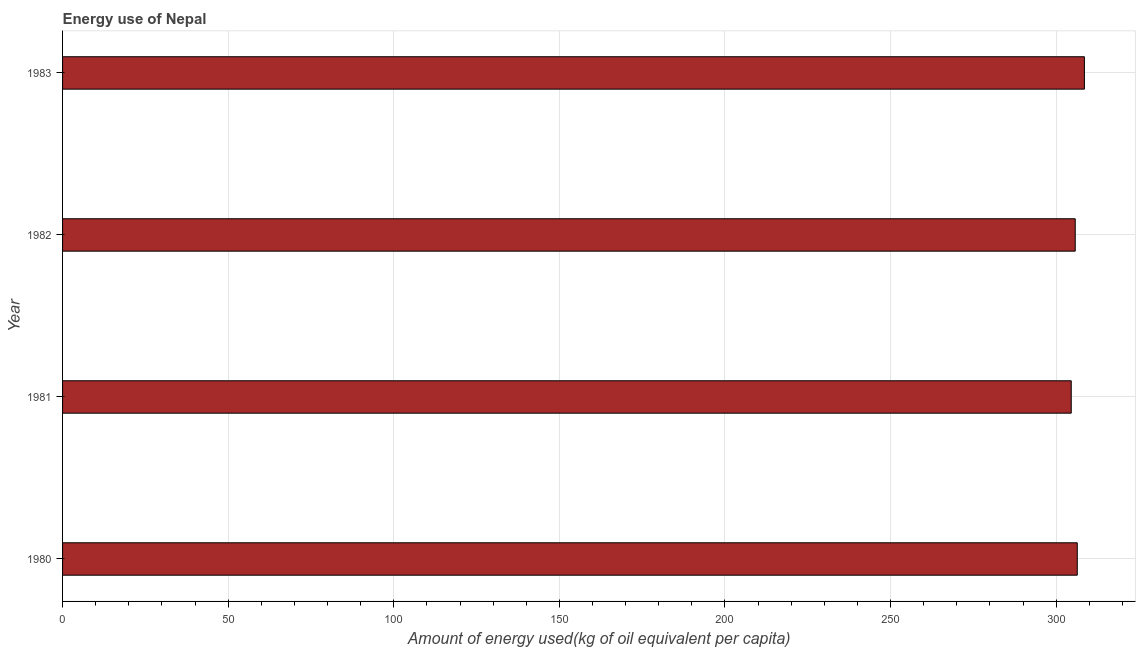What is the title of the graph?
Ensure brevity in your answer.  Energy use of Nepal. What is the label or title of the X-axis?
Offer a very short reply. Amount of energy used(kg of oil equivalent per capita). What is the label or title of the Y-axis?
Your answer should be very brief. Year. What is the amount of energy used in 1983?
Your response must be concise. 308.52. Across all years, what is the maximum amount of energy used?
Your response must be concise. 308.52. Across all years, what is the minimum amount of energy used?
Make the answer very short. 304.54. In which year was the amount of energy used maximum?
Provide a succinct answer. 1983. In which year was the amount of energy used minimum?
Offer a very short reply. 1981. What is the sum of the amount of energy used?
Keep it short and to the point. 1225.16. What is the difference between the amount of energy used in 1982 and 1983?
Provide a short and direct response. -2.77. What is the average amount of energy used per year?
Keep it short and to the point. 306.29. What is the median amount of energy used?
Your answer should be compact. 306.05. In how many years, is the amount of energy used greater than 290 kg?
Provide a short and direct response. 4. Do a majority of the years between 1982 and 1983 (inclusive) have amount of energy used greater than 40 kg?
Your answer should be very brief. Yes. What is the ratio of the amount of energy used in 1980 to that in 1983?
Offer a terse response. 0.99. Is the difference between the amount of energy used in 1980 and 1982 greater than the difference between any two years?
Provide a succinct answer. No. What is the difference between the highest and the second highest amount of energy used?
Your answer should be very brief. 2.15. What is the difference between the highest and the lowest amount of energy used?
Your answer should be very brief. 3.98. In how many years, is the amount of energy used greater than the average amount of energy used taken over all years?
Your answer should be compact. 2. How many bars are there?
Your answer should be very brief. 4. How many years are there in the graph?
Your answer should be very brief. 4. What is the difference between two consecutive major ticks on the X-axis?
Your response must be concise. 50. What is the Amount of energy used(kg of oil equivalent per capita) of 1980?
Ensure brevity in your answer.  306.36. What is the Amount of energy used(kg of oil equivalent per capita) in 1981?
Give a very brief answer. 304.54. What is the Amount of energy used(kg of oil equivalent per capita) of 1982?
Your answer should be compact. 305.75. What is the Amount of energy used(kg of oil equivalent per capita) of 1983?
Provide a succinct answer. 308.52. What is the difference between the Amount of energy used(kg of oil equivalent per capita) in 1980 and 1981?
Give a very brief answer. 1.82. What is the difference between the Amount of energy used(kg of oil equivalent per capita) in 1980 and 1982?
Make the answer very short. 0.61. What is the difference between the Amount of energy used(kg of oil equivalent per capita) in 1980 and 1983?
Your response must be concise. -2.15. What is the difference between the Amount of energy used(kg of oil equivalent per capita) in 1981 and 1982?
Make the answer very short. -1.21. What is the difference between the Amount of energy used(kg of oil equivalent per capita) in 1981 and 1983?
Provide a short and direct response. -3.98. What is the difference between the Amount of energy used(kg of oil equivalent per capita) in 1982 and 1983?
Make the answer very short. -2.77. What is the ratio of the Amount of energy used(kg of oil equivalent per capita) in 1980 to that in 1983?
Ensure brevity in your answer.  0.99. 